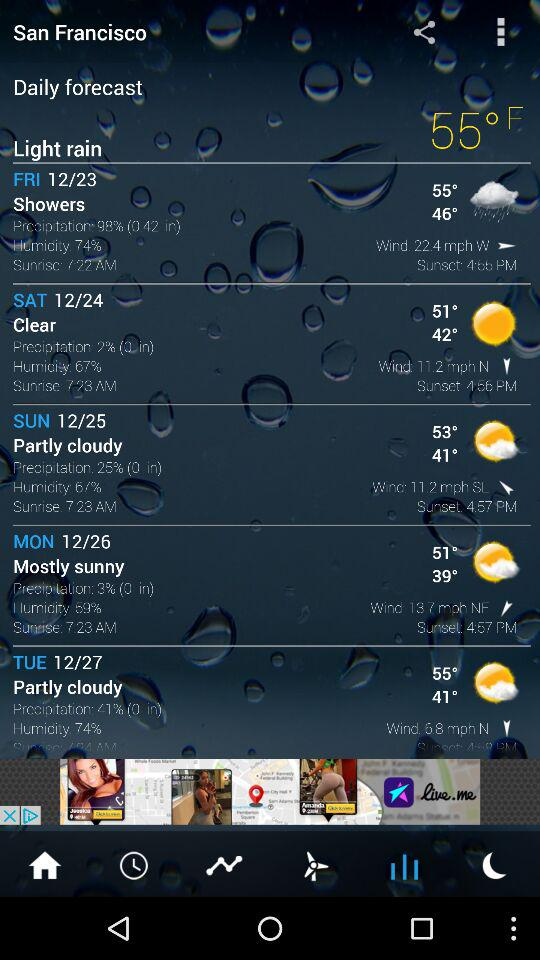How is the weather on Friday? The weather is showery. 